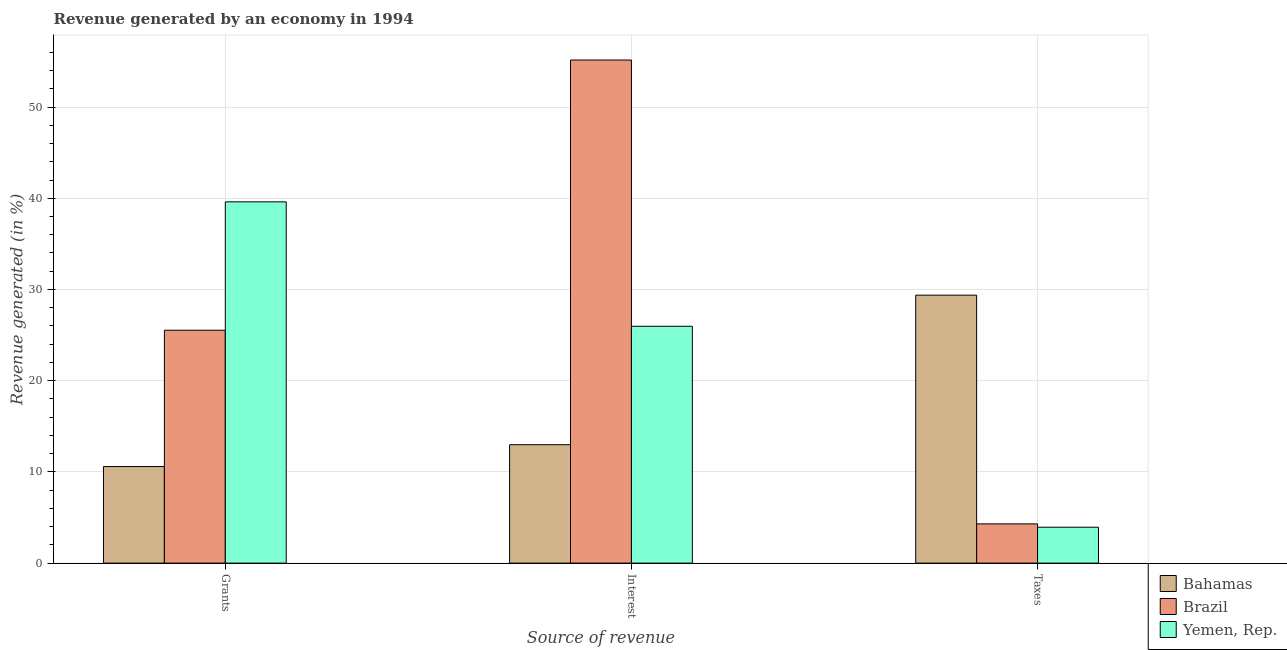Are the number of bars on each tick of the X-axis equal?
Provide a short and direct response. Yes. How many bars are there on the 3rd tick from the left?
Your response must be concise. 3. How many bars are there on the 1st tick from the right?
Ensure brevity in your answer.  3. What is the label of the 3rd group of bars from the left?
Offer a terse response. Taxes. What is the percentage of revenue generated by interest in Yemen, Rep.?
Ensure brevity in your answer.  25.97. Across all countries, what is the maximum percentage of revenue generated by interest?
Make the answer very short. 55.16. Across all countries, what is the minimum percentage of revenue generated by taxes?
Your response must be concise. 3.93. In which country was the percentage of revenue generated by grants maximum?
Your answer should be compact. Yemen, Rep. In which country was the percentage of revenue generated by grants minimum?
Your response must be concise. Bahamas. What is the total percentage of revenue generated by interest in the graph?
Offer a very short reply. 94.1. What is the difference between the percentage of revenue generated by interest in Brazil and that in Yemen, Rep.?
Offer a terse response. 29.19. What is the difference between the percentage of revenue generated by interest in Yemen, Rep. and the percentage of revenue generated by taxes in Bahamas?
Give a very brief answer. -3.41. What is the average percentage of revenue generated by taxes per country?
Make the answer very short. 12.54. What is the difference between the percentage of revenue generated by grants and percentage of revenue generated by interest in Bahamas?
Make the answer very short. -2.4. What is the ratio of the percentage of revenue generated by interest in Bahamas to that in Brazil?
Your answer should be compact. 0.24. Is the percentage of revenue generated by interest in Bahamas less than that in Brazil?
Keep it short and to the point. Yes. Is the difference between the percentage of revenue generated by taxes in Brazil and Bahamas greater than the difference between the percentage of revenue generated by grants in Brazil and Bahamas?
Provide a succinct answer. No. What is the difference between the highest and the second highest percentage of revenue generated by taxes?
Keep it short and to the point. 25.08. What is the difference between the highest and the lowest percentage of revenue generated by interest?
Your answer should be very brief. 42.17. Is the sum of the percentage of revenue generated by interest in Yemen, Rep. and Brazil greater than the maximum percentage of revenue generated by grants across all countries?
Make the answer very short. Yes. What does the 1st bar from the left in Taxes represents?
Provide a succinct answer. Bahamas. What does the 1st bar from the right in Grants represents?
Offer a very short reply. Yemen, Rep. Are all the bars in the graph horizontal?
Your answer should be compact. No. How many countries are there in the graph?
Keep it short and to the point. 3. Does the graph contain any zero values?
Make the answer very short. No. What is the title of the graph?
Keep it short and to the point. Revenue generated by an economy in 1994. What is the label or title of the X-axis?
Keep it short and to the point. Source of revenue. What is the label or title of the Y-axis?
Provide a succinct answer. Revenue generated (in %). What is the Revenue generated (in %) of Bahamas in Grants?
Your answer should be compact. 10.59. What is the Revenue generated (in %) of Brazil in Grants?
Your response must be concise. 25.53. What is the Revenue generated (in %) of Yemen, Rep. in Grants?
Provide a short and direct response. 39.61. What is the Revenue generated (in %) in Bahamas in Interest?
Your response must be concise. 12.98. What is the Revenue generated (in %) of Brazil in Interest?
Provide a short and direct response. 55.16. What is the Revenue generated (in %) in Yemen, Rep. in Interest?
Ensure brevity in your answer.  25.97. What is the Revenue generated (in %) in Bahamas in Taxes?
Give a very brief answer. 29.38. What is the Revenue generated (in %) in Brazil in Taxes?
Offer a terse response. 4.3. What is the Revenue generated (in %) of Yemen, Rep. in Taxes?
Your response must be concise. 3.93. Across all Source of revenue, what is the maximum Revenue generated (in %) in Bahamas?
Your answer should be compact. 29.38. Across all Source of revenue, what is the maximum Revenue generated (in %) in Brazil?
Offer a very short reply. 55.16. Across all Source of revenue, what is the maximum Revenue generated (in %) in Yemen, Rep.?
Your answer should be compact. 39.61. Across all Source of revenue, what is the minimum Revenue generated (in %) in Bahamas?
Your response must be concise. 10.59. Across all Source of revenue, what is the minimum Revenue generated (in %) of Brazil?
Offer a very short reply. 4.3. Across all Source of revenue, what is the minimum Revenue generated (in %) in Yemen, Rep.?
Give a very brief answer. 3.93. What is the total Revenue generated (in %) in Bahamas in the graph?
Ensure brevity in your answer.  52.95. What is the total Revenue generated (in %) of Brazil in the graph?
Make the answer very short. 84.99. What is the total Revenue generated (in %) in Yemen, Rep. in the graph?
Give a very brief answer. 69.51. What is the difference between the Revenue generated (in %) in Bahamas in Grants and that in Interest?
Make the answer very short. -2.4. What is the difference between the Revenue generated (in %) in Brazil in Grants and that in Interest?
Give a very brief answer. -29.62. What is the difference between the Revenue generated (in %) in Yemen, Rep. in Grants and that in Interest?
Offer a very short reply. 13.64. What is the difference between the Revenue generated (in %) of Bahamas in Grants and that in Taxes?
Make the answer very short. -18.79. What is the difference between the Revenue generated (in %) in Brazil in Grants and that in Taxes?
Your answer should be compact. 21.23. What is the difference between the Revenue generated (in %) in Yemen, Rep. in Grants and that in Taxes?
Provide a succinct answer. 35.67. What is the difference between the Revenue generated (in %) in Bahamas in Interest and that in Taxes?
Give a very brief answer. -16.4. What is the difference between the Revenue generated (in %) of Brazil in Interest and that in Taxes?
Your response must be concise. 50.85. What is the difference between the Revenue generated (in %) in Yemen, Rep. in Interest and that in Taxes?
Give a very brief answer. 22.03. What is the difference between the Revenue generated (in %) in Bahamas in Grants and the Revenue generated (in %) in Brazil in Interest?
Make the answer very short. -44.57. What is the difference between the Revenue generated (in %) of Bahamas in Grants and the Revenue generated (in %) of Yemen, Rep. in Interest?
Your answer should be very brief. -15.38. What is the difference between the Revenue generated (in %) in Brazil in Grants and the Revenue generated (in %) in Yemen, Rep. in Interest?
Keep it short and to the point. -0.43. What is the difference between the Revenue generated (in %) in Bahamas in Grants and the Revenue generated (in %) in Brazil in Taxes?
Provide a short and direct response. 6.28. What is the difference between the Revenue generated (in %) of Bahamas in Grants and the Revenue generated (in %) of Yemen, Rep. in Taxes?
Your response must be concise. 6.65. What is the difference between the Revenue generated (in %) in Brazil in Grants and the Revenue generated (in %) in Yemen, Rep. in Taxes?
Your response must be concise. 21.6. What is the difference between the Revenue generated (in %) in Bahamas in Interest and the Revenue generated (in %) in Brazil in Taxes?
Give a very brief answer. 8.68. What is the difference between the Revenue generated (in %) in Bahamas in Interest and the Revenue generated (in %) in Yemen, Rep. in Taxes?
Provide a succinct answer. 9.05. What is the difference between the Revenue generated (in %) in Brazil in Interest and the Revenue generated (in %) in Yemen, Rep. in Taxes?
Offer a terse response. 51.22. What is the average Revenue generated (in %) of Bahamas per Source of revenue?
Make the answer very short. 17.65. What is the average Revenue generated (in %) in Brazil per Source of revenue?
Provide a short and direct response. 28.33. What is the average Revenue generated (in %) of Yemen, Rep. per Source of revenue?
Offer a very short reply. 23.17. What is the difference between the Revenue generated (in %) in Bahamas and Revenue generated (in %) in Brazil in Grants?
Ensure brevity in your answer.  -14.95. What is the difference between the Revenue generated (in %) in Bahamas and Revenue generated (in %) in Yemen, Rep. in Grants?
Make the answer very short. -29.02. What is the difference between the Revenue generated (in %) in Brazil and Revenue generated (in %) in Yemen, Rep. in Grants?
Offer a terse response. -14.07. What is the difference between the Revenue generated (in %) of Bahamas and Revenue generated (in %) of Brazil in Interest?
Your response must be concise. -42.17. What is the difference between the Revenue generated (in %) of Bahamas and Revenue generated (in %) of Yemen, Rep. in Interest?
Provide a succinct answer. -12.98. What is the difference between the Revenue generated (in %) of Brazil and Revenue generated (in %) of Yemen, Rep. in Interest?
Your response must be concise. 29.19. What is the difference between the Revenue generated (in %) of Bahamas and Revenue generated (in %) of Brazil in Taxes?
Your response must be concise. 25.08. What is the difference between the Revenue generated (in %) of Bahamas and Revenue generated (in %) of Yemen, Rep. in Taxes?
Make the answer very short. 25.44. What is the difference between the Revenue generated (in %) of Brazil and Revenue generated (in %) of Yemen, Rep. in Taxes?
Provide a short and direct response. 0.37. What is the ratio of the Revenue generated (in %) of Bahamas in Grants to that in Interest?
Ensure brevity in your answer.  0.82. What is the ratio of the Revenue generated (in %) of Brazil in Grants to that in Interest?
Your answer should be compact. 0.46. What is the ratio of the Revenue generated (in %) of Yemen, Rep. in Grants to that in Interest?
Your answer should be compact. 1.53. What is the ratio of the Revenue generated (in %) of Bahamas in Grants to that in Taxes?
Offer a terse response. 0.36. What is the ratio of the Revenue generated (in %) of Brazil in Grants to that in Taxes?
Offer a very short reply. 5.94. What is the ratio of the Revenue generated (in %) in Yemen, Rep. in Grants to that in Taxes?
Offer a terse response. 10.07. What is the ratio of the Revenue generated (in %) of Bahamas in Interest to that in Taxes?
Your answer should be compact. 0.44. What is the ratio of the Revenue generated (in %) of Brazil in Interest to that in Taxes?
Your answer should be very brief. 12.82. What is the ratio of the Revenue generated (in %) in Yemen, Rep. in Interest to that in Taxes?
Offer a very short reply. 6.6. What is the difference between the highest and the second highest Revenue generated (in %) in Bahamas?
Ensure brevity in your answer.  16.4. What is the difference between the highest and the second highest Revenue generated (in %) in Brazil?
Your response must be concise. 29.62. What is the difference between the highest and the second highest Revenue generated (in %) in Yemen, Rep.?
Your response must be concise. 13.64. What is the difference between the highest and the lowest Revenue generated (in %) in Bahamas?
Ensure brevity in your answer.  18.79. What is the difference between the highest and the lowest Revenue generated (in %) in Brazil?
Provide a succinct answer. 50.85. What is the difference between the highest and the lowest Revenue generated (in %) of Yemen, Rep.?
Your response must be concise. 35.67. 